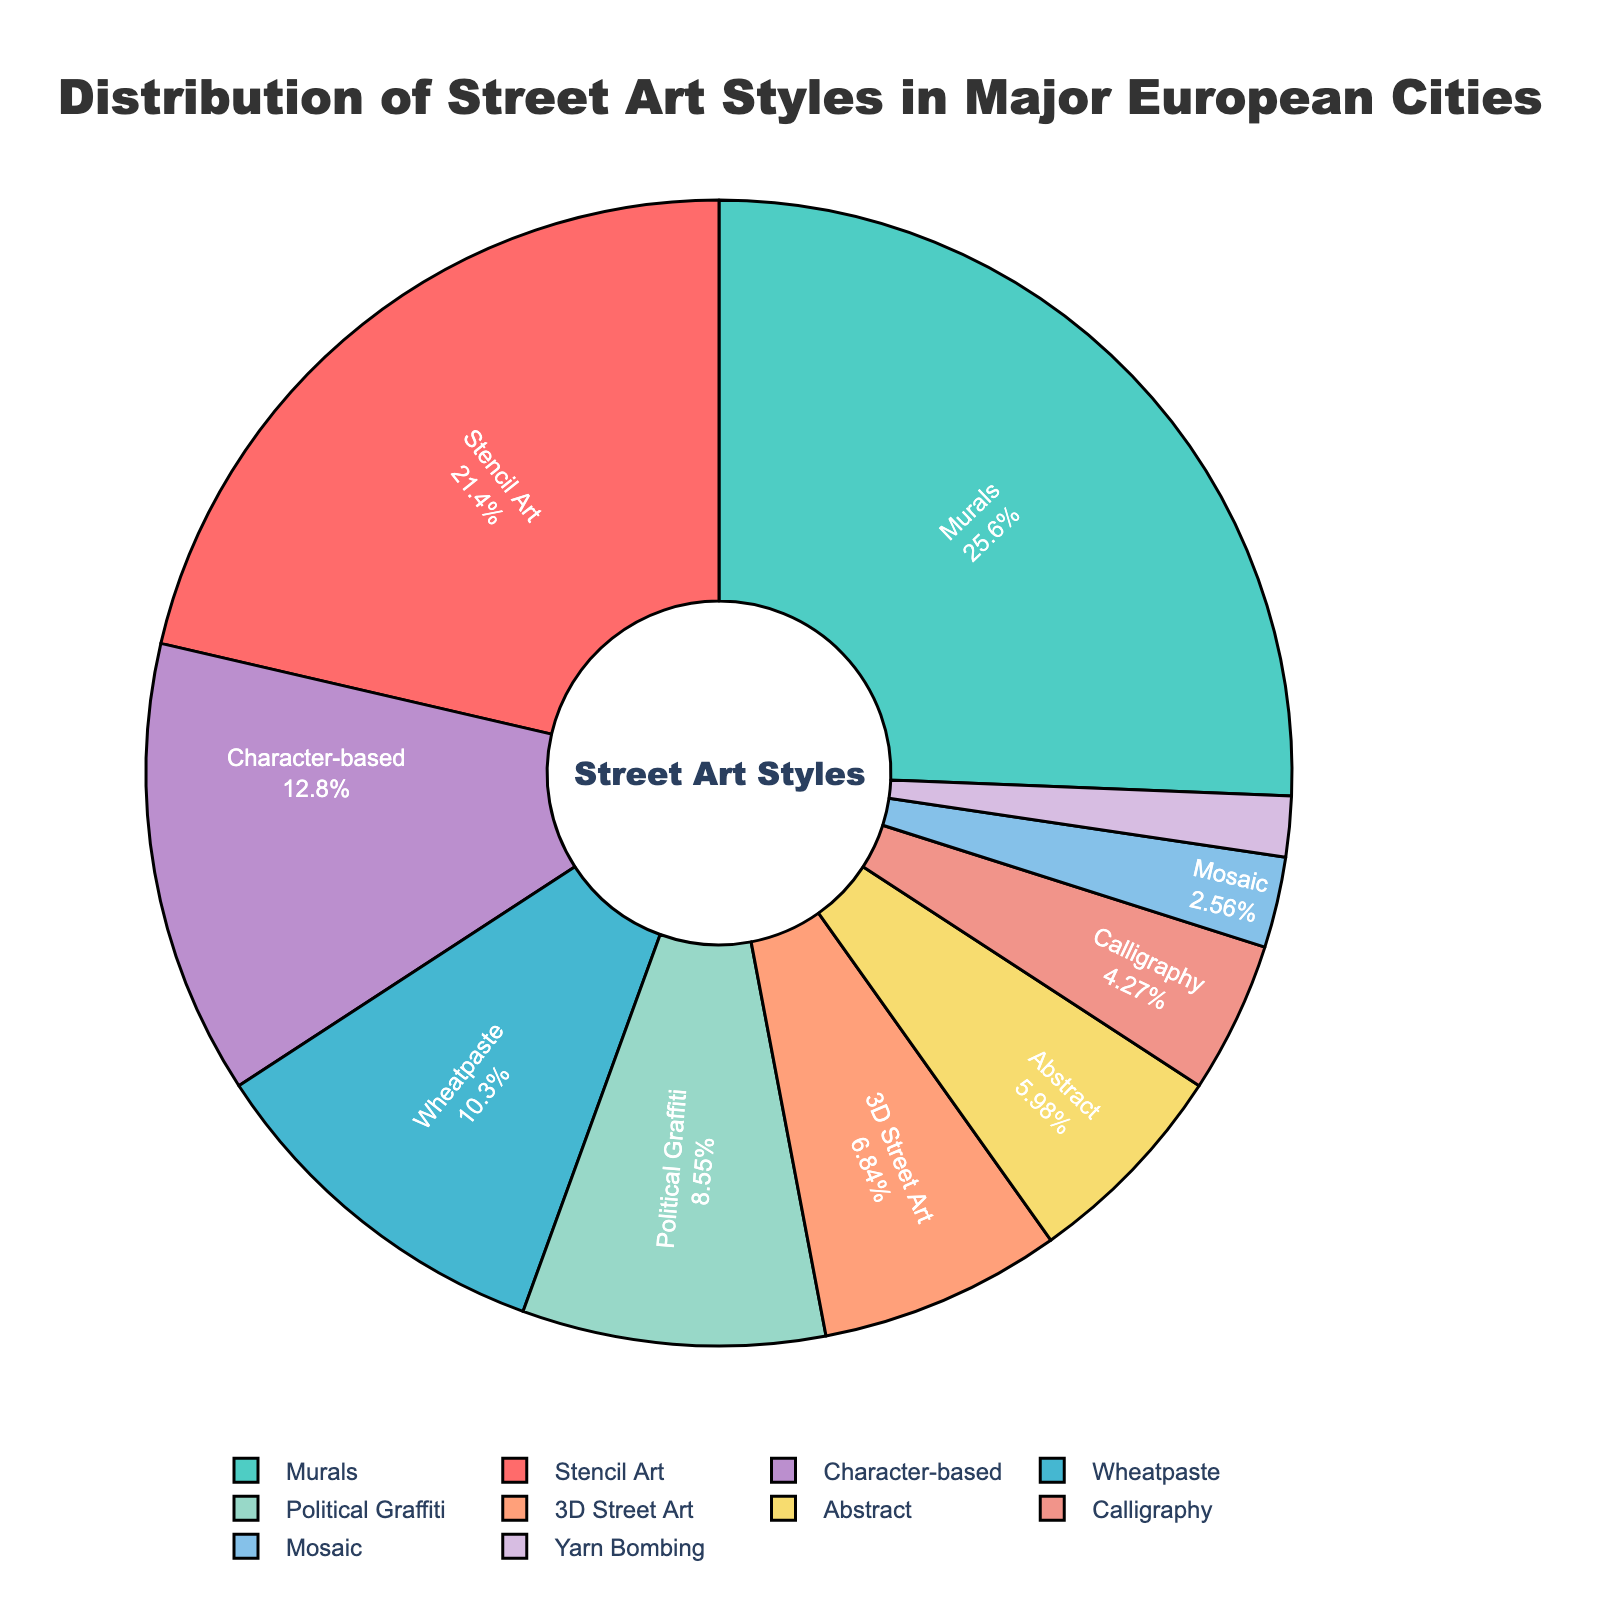What is the most common street art style in major European cities according to the chart? The chart shows that Murals have the largest portion, occupying 30% of the distribution.
Answer: Murals Which street art style has a lower percentage, Wheatpaste or Political Graffiti? The chart indicates that Wheatpaste has 12% while Political Graffiti has 10%, making Political Graffiti the lower percentage.
Answer: Political Graffiti What is the combined percentage of Calligraphy, Mosaic, and Yarn Bombing? Adding the percentages from the chart: Calligraphy (5%), Mosaic (3%), Yarn Bombing (2%) results in 5 + 3 + 2 = 10%.
Answer: 10% Compare the proportions of 3D Street Art and Character-based street art. According to the chart, 3D Street Art accounts for 8% and Character-based street art accounts for 15%. Therefore, Character-based street art is more common.
Answer: Character-based street art Is Abstract street art more or less common than Political Graffiti? The chart shows that Abstract street art is 7% while Political Graffiti is 10%, making Abstract street art less common.
Answer: Less common Which style of street art is represented by the largest red section in the pie chart? Associating the color red from the chart, the Stencil Art is represented in the red section with 25% of the distribution.
Answer: Stencil Art How much larger is the percentage of Murals compared to 3D Street Art? Subtracting 3D Street Art's percentage (8%) from Murals' percentage (30%), we get 30 - 8 = 22%.
Answer: 22% If you combine the percentages of Stencil Art, Character-based, and Wheatpaste, what percentage do you get? Adding the percentages from the chart: Stencil Art (25%), Character-based (15%), and Wheatpaste (12%) gives 25 + 15 + 12 = 52%.
Answer: 52% What percentage of street art styles are represented by less than 10% each? The styles below 10% are: Wheatpaste (12%), 3D Street Art (8%), Political Graffiti (10%), Abstract (7%), Character-based (15%), Calligraphy (5%), Mosaic (3%), Yarn Bombing (2%). Only Wheatpaste and Character-based are above 10%, so adding remaining percentages: 3D Street Art (8%) + Political Graffiti (10%) + Abstract (7%) + Calligraphy (5%) + Mosaic (3%) + Yarn Bombing (2%) = 35%.
Answer: 35% Identify the street art styles that have percentages represented in blue and green colors. From the chart's color association, the blue segment represents Character-based street art with 15%, and the green segment represents Murals with 30%.
Answer: Character-based street art, Murals 